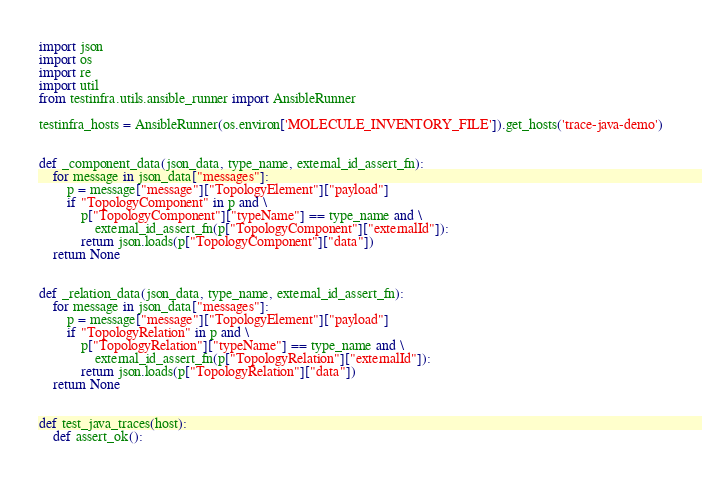<code> <loc_0><loc_0><loc_500><loc_500><_Python_>import json
import os
import re
import util
from testinfra.utils.ansible_runner import AnsibleRunner

testinfra_hosts = AnsibleRunner(os.environ['MOLECULE_INVENTORY_FILE']).get_hosts('trace-java-demo')


def _component_data(json_data, type_name, external_id_assert_fn):
    for message in json_data["messages"]:
        p = message["message"]["TopologyElement"]["payload"]
        if "TopologyComponent" in p and \
            p["TopologyComponent"]["typeName"] == type_name and \
                external_id_assert_fn(p["TopologyComponent"]["externalId"]):
            return json.loads(p["TopologyComponent"]["data"])
    return None


def _relation_data(json_data, type_name, external_id_assert_fn):
    for message in json_data["messages"]:
        p = message["message"]["TopologyElement"]["payload"]
        if "TopologyRelation" in p and \
            p["TopologyRelation"]["typeName"] == type_name and \
                external_id_assert_fn(p["TopologyRelation"]["externalId"]):
            return json.loads(p["TopologyRelation"]["data"])
    return None


def test_java_traces(host):
    def assert_ok():</code> 